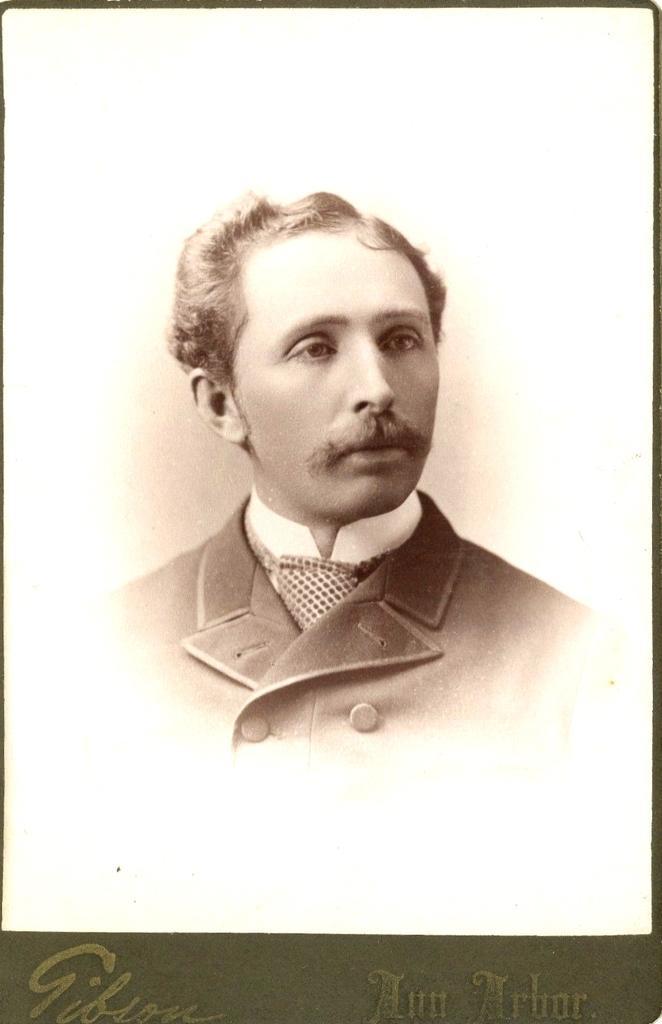Describe this image in one or two sentences. In this image I can see the photo of the person and there is a white background. I can see something is written on the bottom of the image. 